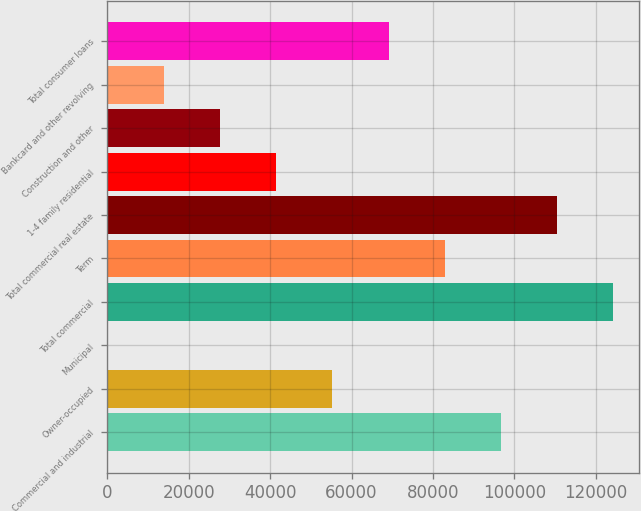Convert chart. <chart><loc_0><loc_0><loc_500><loc_500><bar_chart><fcel>Commercial and industrial<fcel>Owner-occupied<fcel>Municipal<fcel>Total commercial<fcel>Term<fcel>Total commercial real estate<fcel>1-4 family residential<fcel>Construction and other<fcel>Bankcard and other revolving<fcel>Total consumer loans<nl><fcel>96760.1<fcel>55311.2<fcel>46<fcel>124393<fcel>82943.8<fcel>110576<fcel>41494.9<fcel>27678.6<fcel>13862.3<fcel>69127.5<nl></chart> 